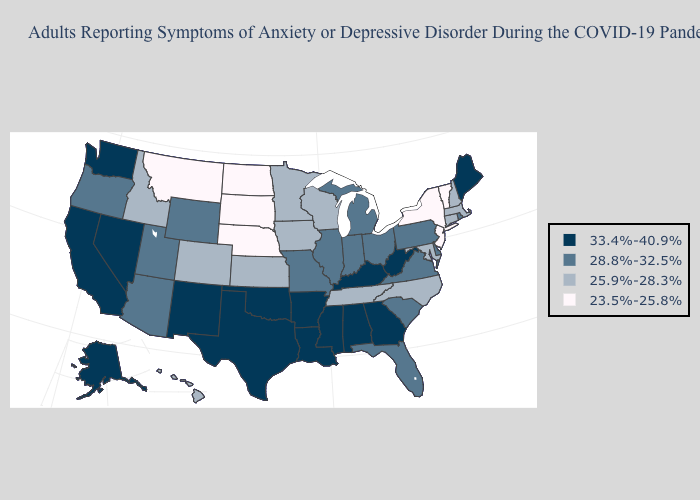What is the value of Montana?
Short answer required. 23.5%-25.8%. Name the states that have a value in the range 28.8%-32.5%?
Concise answer only. Arizona, Delaware, Florida, Illinois, Indiana, Michigan, Missouri, Ohio, Oregon, Pennsylvania, Rhode Island, South Carolina, Utah, Virginia, Wyoming. What is the value of Florida?
Concise answer only. 28.8%-32.5%. Name the states that have a value in the range 33.4%-40.9%?
Be succinct. Alabama, Alaska, Arkansas, California, Georgia, Kentucky, Louisiana, Maine, Mississippi, Nevada, New Mexico, Oklahoma, Texas, Washington, West Virginia. What is the value of South Dakota?
Keep it brief. 23.5%-25.8%. What is the value of Georgia?
Answer briefly. 33.4%-40.9%. What is the value of Maine?
Be succinct. 33.4%-40.9%. Among the states that border South Carolina , which have the lowest value?
Short answer required. North Carolina. Does the map have missing data?
Be succinct. No. Among the states that border Massachusetts , which have the highest value?
Short answer required. Rhode Island. What is the value of Tennessee?
Be succinct. 25.9%-28.3%. Name the states that have a value in the range 23.5%-25.8%?
Answer briefly. Montana, Nebraska, New Jersey, New York, North Dakota, South Dakota, Vermont. What is the highest value in states that border Kentucky?
Write a very short answer. 33.4%-40.9%. Which states have the lowest value in the South?
Write a very short answer. Maryland, North Carolina, Tennessee. What is the lowest value in states that border Kentucky?
Write a very short answer. 25.9%-28.3%. 